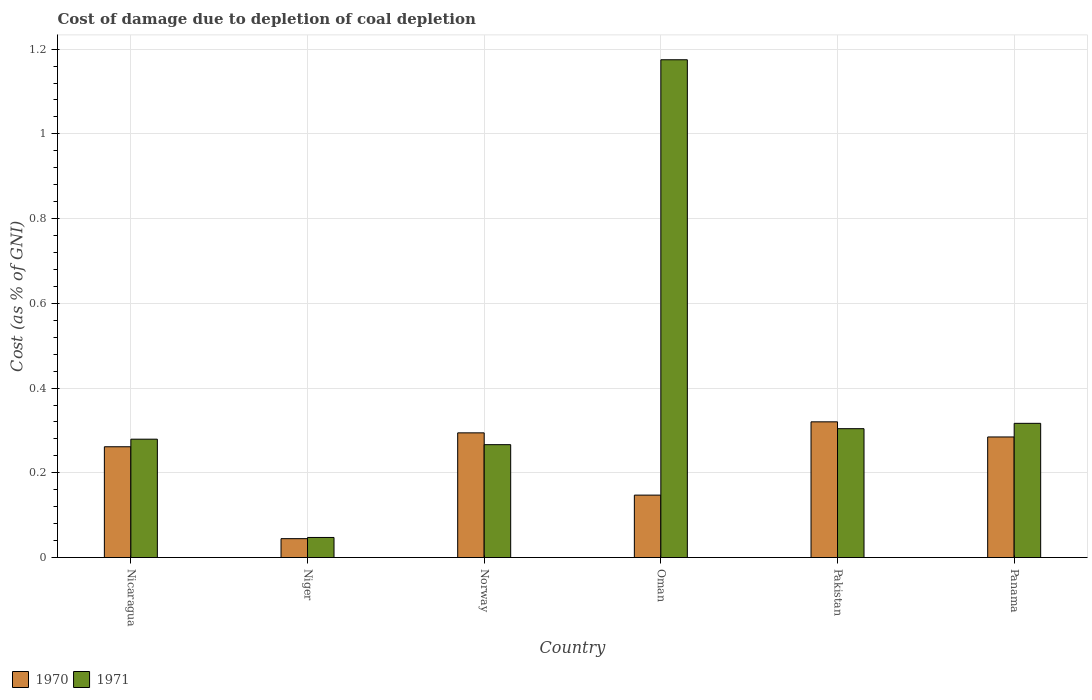How many different coloured bars are there?
Ensure brevity in your answer.  2. Are the number of bars per tick equal to the number of legend labels?
Make the answer very short. Yes. What is the label of the 1st group of bars from the left?
Offer a terse response. Nicaragua. In how many cases, is the number of bars for a given country not equal to the number of legend labels?
Offer a very short reply. 0. What is the cost of damage caused due to coal depletion in 1970 in Panama?
Make the answer very short. 0.28. Across all countries, what is the maximum cost of damage caused due to coal depletion in 1970?
Provide a short and direct response. 0.32. Across all countries, what is the minimum cost of damage caused due to coal depletion in 1971?
Your answer should be very brief. 0.05. In which country was the cost of damage caused due to coal depletion in 1970 maximum?
Provide a succinct answer. Pakistan. In which country was the cost of damage caused due to coal depletion in 1971 minimum?
Your response must be concise. Niger. What is the total cost of damage caused due to coal depletion in 1970 in the graph?
Your answer should be very brief. 1.35. What is the difference between the cost of damage caused due to coal depletion in 1971 in Niger and that in Panama?
Provide a succinct answer. -0.27. What is the difference between the cost of damage caused due to coal depletion in 1971 in Niger and the cost of damage caused due to coal depletion in 1970 in Nicaragua?
Ensure brevity in your answer.  -0.21. What is the average cost of damage caused due to coal depletion in 1971 per country?
Offer a very short reply. 0.4. What is the difference between the cost of damage caused due to coal depletion of/in 1971 and cost of damage caused due to coal depletion of/in 1970 in Niger?
Your response must be concise. 0. In how many countries, is the cost of damage caused due to coal depletion in 1971 greater than 0.08 %?
Your response must be concise. 5. What is the ratio of the cost of damage caused due to coal depletion in 1970 in Niger to that in Panama?
Your answer should be very brief. 0.16. Is the cost of damage caused due to coal depletion in 1971 in Norway less than that in Panama?
Keep it short and to the point. Yes. Is the difference between the cost of damage caused due to coal depletion in 1971 in Oman and Panama greater than the difference between the cost of damage caused due to coal depletion in 1970 in Oman and Panama?
Your answer should be very brief. Yes. What is the difference between the highest and the second highest cost of damage caused due to coal depletion in 1971?
Ensure brevity in your answer.  -0.86. What is the difference between the highest and the lowest cost of damage caused due to coal depletion in 1971?
Your answer should be compact. 1.13. In how many countries, is the cost of damage caused due to coal depletion in 1971 greater than the average cost of damage caused due to coal depletion in 1971 taken over all countries?
Offer a terse response. 1. Is the sum of the cost of damage caused due to coal depletion in 1970 in Pakistan and Panama greater than the maximum cost of damage caused due to coal depletion in 1971 across all countries?
Offer a very short reply. No. What does the 1st bar from the left in Oman represents?
Offer a terse response. 1970. How many bars are there?
Give a very brief answer. 12. Are all the bars in the graph horizontal?
Provide a succinct answer. No. What is the difference between two consecutive major ticks on the Y-axis?
Make the answer very short. 0.2. Where does the legend appear in the graph?
Provide a short and direct response. Bottom left. How many legend labels are there?
Offer a terse response. 2. How are the legend labels stacked?
Offer a terse response. Horizontal. What is the title of the graph?
Provide a succinct answer. Cost of damage due to depletion of coal depletion. What is the label or title of the Y-axis?
Give a very brief answer. Cost (as % of GNI). What is the Cost (as % of GNI) of 1970 in Nicaragua?
Provide a succinct answer. 0.26. What is the Cost (as % of GNI) in 1971 in Nicaragua?
Make the answer very short. 0.28. What is the Cost (as % of GNI) in 1970 in Niger?
Your answer should be compact. 0.04. What is the Cost (as % of GNI) in 1971 in Niger?
Provide a succinct answer. 0.05. What is the Cost (as % of GNI) in 1970 in Norway?
Provide a succinct answer. 0.29. What is the Cost (as % of GNI) of 1971 in Norway?
Keep it short and to the point. 0.27. What is the Cost (as % of GNI) of 1970 in Oman?
Provide a short and direct response. 0.15. What is the Cost (as % of GNI) in 1971 in Oman?
Provide a succinct answer. 1.17. What is the Cost (as % of GNI) in 1970 in Pakistan?
Keep it short and to the point. 0.32. What is the Cost (as % of GNI) of 1971 in Pakistan?
Give a very brief answer. 0.3. What is the Cost (as % of GNI) of 1970 in Panama?
Ensure brevity in your answer.  0.28. What is the Cost (as % of GNI) of 1971 in Panama?
Give a very brief answer. 0.32. Across all countries, what is the maximum Cost (as % of GNI) of 1970?
Your response must be concise. 0.32. Across all countries, what is the maximum Cost (as % of GNI) in 1971?
Your answer should be very brief. 1.17. Across all countries, what is the minimum Cost (as % of GNI) of 1970?
Offer a terse response. 0.04. Across all countries, what is the minimum Cost (as % of GNI) of 1971?
Ensure brevity in your answer.  0.05. What is the total Cost (as % of GNI) in 1970 in the graph?
Keep it short and to the point. 1.35. What is the total Cost (as % of GNI) of 1971 in the graph?
Your answer should be very brief. 2.39. What is the difference between the Cost (as % of GNI) of 1970 in Nicaragua and that in Niger?
Offer a very short reply. 0.22. What is the difference between the Cost (as % of GNI) of 1971 in Nicaragua and that in Niger?
Give a very brief answer. 0.23. What is the difference between the Cost (as % of GNI) in 1970 in Nicaragua and that in Norway?
Give a very brief answer. -0.03. What is the difference between the Cost (as % of GNI) in 1971 in Nicaragua and that in Norway?
Your answer should be very brief. 0.01. What is the difference between the Cost (as % of GNI) of 1970 in Nicaragua and that in Oman?
Your response must be concise. 0.11. What is the difference between the Cost (as % of GNI) in 1971 in Nicaragua and that in Oman?
Your answer should be very brief. -0.9. What is the difference between the Cost (as % of GNI) in 1970 in Nicaragua and that in Pakistan?
Provide a succinct answer. -0.06. What is the difference between the Cost (as % of GNI) of 1971 in Nicaragua and that in Pakistan?
Provide a succinct answer. -0.02. What is the difference between the Cost (as % of GNI) of 1970 in Nicaragua and that in Panama?
Your answer should be compact. -0.02. What is the difference between the Cost (as % of GNI) of 1971 in Nicaragua and that in Panama?
Your answer should be very brief. -0.04. What is the difference between the Cost (as % of GNI) in 1970 in Niger and that in Norway?
Keep it short and to the point. -0.25. What is the difference between the Cost (as % of GNI) in 1971 in Niger and that in Norway?
Give a very brief answer. -0.22. What is the difference between the Cost (as % of GNI) in 1970 in Niger and that in Oman?
Ensure brevity in your answer.  -0.1. What is the difference between the Cost (as % of GNI) in 1971 in Niger and that in Oman?
Your answer should be compact. -1.13. What is the difference between the Cost (as % of GNI) of 1970 in Niger and that in Pakistan?
Your answer should be very brief. -0.28. What is the difference between the Cost (as % of GNI) in 1971 in Niger and that in Pakistan?
Provide a succinct answer. -0.26. What is the difference between the Cost (as % of GNI) in 1970 in Niger and that in Panama?
Make the answer very short. -0.24. What is the difference between the Cost (as % of GNI) of 1971 in Niger and that in Panama?
Your answer should be compact. -0.27. What is the difference between the Cost (as % of GNI) in 1970 in Norway and that in Oman?
Offer a very short reply. 0.15. What is the difference between the Cost (as % of GNI) in 1971 in Norway and that in Oman?
Your answer should be very brief. -0.91. What is the difference between the Cost (as % of GNI) of 1970 in Norway and that in Pakistan?
Keep it short and to the point. -0.03. What is the difference between the Cost (as % of GNI) of 1971 in Norway and that in Pakistan?
Offer a terse response. -0.04. What is the difference between the Cost (as % of GNI) of 1970 in Norway and that in Panama?
Offer a terse response. 0.01. What is the difference between the Cost (as % of GNI) in 1971 in Norway and that in Panama?
Provide a short and direct response. -0.05. What is the difference between the Cost (as % of GNI) in 1970 in Oman and that in Pakistan?
Your response must be concise. -0.17. What is the difference between the Cost (as % of GNI) in 1971 in Oman and that in Pakistan?
Ensure brevity in your answer.  0.87. What is the difference between the Cost (as % of GNI) in 1970 in Oman and that in Panama?
Provide a short and direct response. -0.14. What is the difference between the Cost (as % of GNI) in 1971 in Oman and that in Panama?
Your answer should be very brief. 0.86. What is the difference between the Cost (as % of GNI) in 1970 in Pakistan and that in Panama?
Ensure brevity in your answer.  0.04. What is the difference between the Cost (as % of GNI) in 1971 in Pakistan and that in Panama?
Offer a terse response. -0.01. What is the difference between the Cost (as % of GNI) in 1970 in Nicaragua and the Cost (as % of GNI) in 1971 in Niger?
Provide a succinct answer. 0.21. What is the difference between the Cost (as % of GNI) in 1970 in Nicaragua and the Cost (as % of GNI) in 1971 in Norway?
Your answer should be very brief. -0. What is the difference between the Cost (as % of GNI) in 1970 in Nicaragua and the Cost (as % of GNI) in 1971 in Oman?
Offer a very short reply. -0.91. What is the difference between the Cost (as % of GNI) of 1970 in Nicaragua and the Cost (as % of GNI) of 1971 in Pakistan?
Offer a very short reply. -0.04. What is the difference between the Cost (as % of GNI) in 1970 in Nicaragua and the Cost (as % of GNI) in 1971 in Panama?
Provide a succinct answer. -0.06. What is the difference between the Cost (as % of GNI) of 1970 in Niger and the Cost (as % of GNI) of 1971 in Norway?
Offer a terse response. -0.22. What is the difference between the Cost (as % of GNI) of 1970 in Niger and the Cost (as % of GNI) of 1971 in Oman?
Offer a terse response. -1.13. What is the difference between the Cost (as % of GNI) of 1970 in Niger and the Cost (as % of GNI) of 1971 in Pakistan?
Your answer should be very brief. -0.26. What is the difference between the Cost (as % of GNI) of 1970 in Niger and the Cost (as % of GNI) of 1971 in Panama?
Offer a terse response. -0.27. What is the difference between the Cost (as % of GNI) in 1970 in Norway and the Cost (as % of GNI) in 1971 in Oman?
Offer a terse response. -0.88. What is the difference between the Cost (as % of GNI) in 1970 in Norway and the Cost (as % of GNI) in 1971 in Pakistan?
Ensure brevity in your answer.  -0.01. What is the difference between the Cost (as % of GNI) in 1970 in Norway and the Cost (as % of GNI) in 1971 in Panama?
Keep it short and to the point. -0.02. What is the difference between the Cost (as % of GNI) of 1970 in Oman and the Cost (as % of GNI) of 1971 in Pakistan?
Offer a terse response. -0.16. What is the difference between the Cost (as % of GNI) of 1970 in Oman and the Cost (as % of GNI) of 1971 in Panama?
Your answer should be very brief. -0.17. What is the difference between the Cost (as % of GNI) in 1970 in Pakistan and the Cost (as % of GNI) in 1971 in Panama?
Your answer should be very brief. 0. What is the average Cost (as % of GNI) in 1970 per country?
Your answer should be very brief. 0.23. What is the average Cost (as % of GNI) in 1971 per country?
Your answer should be compact. 0.4. What is the difference between the Cost (as % of GNI) in 1970 and Cost (as % of GNI) in 1971 in Nicaragua?
Provide a short and direct response. -0.02. What is the difference between the Cost (as % of GNI) of 1970 and Cost (as % of GNI) of 1971 in Niger?
Your answer should be compact. -0. What is the difference between the Cost (as % of GNI) of 1970 and Cost (as % of GNI) of 1971 in Norway?
Offer a very short reply. 0.03. What is the difference between the Cost (as % of GNI) in 1970 and Cost (as % of GNI) in 1971 in Oman?
Give a very brief answer. -1.03. What is the difference between the Cost (as % of GNI) of 1970 and Cost (as % of GNI) of 1971 in Pakistan?
Provide a short and direct response. 0.02. What is the difference between the Cost (as % of GNI) in 1970 and Cost (as % of GNI) in 1971 in Panama?
Your answer should be compact. -0.03. What is the ratio of the Cost (as % of GNI) of 1970 in Nicaragua to that in Niger?
Give a very brief answer. 5.87. What is the ratio of the Cost (as % of GNI) in 1971 in Nicaragua to that in Niger?
Your answer should be very brief. 5.9. What is the ratio of the Cost (as % of GNI) in 1970 in Nicaragua to that in Norway?
Your answer should be very brief. 0.89. What is the ratio of the Cost (as % of GNI) of 1971 in Nicaragua to that in Norway?
Your response must be concise. 1.05. What is the ratio of the Cost (as % of GNI) in 1970 in Nicaragua to that in Oman?
Provide a succinct answer. 1.77. What is the ratio of the Cost (as % of GNI) in 1971 in Nicaragua to that in Oman?
Your answer should be very brief. 0.24. What is the ratio of the Cost (as % of GNI) in 1970 in Nicaragua to that in Pakistan?
Offer a terse response. 0.82. What is the ratio of the Cost (as % of GNI) of 1971 in Nicaragua to that in Pakistan?
Offer a terse response. 0.92. What is the ratio of the Cost (as % of GNI) of 1970 in Nicaragua to that in Panama?
Make the answer very short. 0.92. What is the ratio of the Cost (as % of GNI) in 1971 in Nicaragua to that in Panama?
Offer a very short reply. 0.88. What is the ratio of the Cost (as % of GNI) of 1970 in Niger to that in Norway?
Provide a short and direct response. 0.15. What is the ratio of the Cost (as % of GNI) in 1971 in Niger to that in Norway?
Offer a very short reply. 0.18. What is the ratio of the Cost (as % of GNI) of 1970 in Niger to that in Oman?
Give a very brief answer. 0.3. What is the ratio of the Cost (as % of GNI) of 1971 in Niger to that in Oman?
Provide a succinct answer. 0.04. What is the ratio of the Cost (as % of GNI) of 1970 in Niger to that in Pakistan?
Make the answer very short. 0.14. What is the ratio of the Cost (as % of GNI) of 1971 in Niger to that in Pakistan?
Offer a terse response. 0.16. What is the ratio of the Cost (as % of GNI) in 1970 in Niger to that in Panama?
Your response must be concise. 0.16. What is the ratio of the Cost (as % of GNI) in 1971 in Niger to that in Panama?
Your response must be concise. 0.15. What is the ratio of the Cost (as % of GNI) of 1970 in Norway to that in Oman?
Provide a succinct answer. 2. What is the ratio of the Cost (as % of GNI) of 1971 in Norway to that in Oman?
Give a very brief answer. 0.23. What is the ratio of the Cost (as % of GNI) of 1970 in Norway to that in Pakistan?
Provide a short and direct response. 0.92. What is the ratio of the Cost (as % of GNI) in 1971 in Norway to that in Pakistan?
Your answer should be very brief. 0.88. What is the ratio of the Cost (as % of GNI) in 1970 in Norway to that in Panama?
Give a very brief answer. 1.03. What is the ratio of the Cost (as % of GNI) of 1971 in Norway to that in Panama?
Keep it short and to the point. 0.84. What is the ratio of the Cost (as % of GNI) of 1970 in Oman to that in Pakistan?
Ensure brevity in your answer.  0.46. What is the ratio of the Cost (as % of GNI) of 1971 in Oman to that in Pakistan?
Ensure brevity in your answer.  3.86. What is the ratio of the Cost (as % of GNI) in 1970 in Oman to that in Panama?
Your answer should be very brief. 0.52. What is the ratio of the Cost (as % of GNI) in 1971 in Oman to that in Panama?
Offer a very short reply. 3.71. What is the ratio of the Cost (as % of GNI) of 1970 in Pakistan to that in Panama?
Your response must be concise. 1.13. What is the ratio of the Cost (as % of GNI) in 1971 in Pakistan to that in Panama?
Keep it short and to the point. 0.96. What is the difference between the highest and the second highest Cost (as % of GNI) in 1970?
Ensure brevity in your answer.  0.03. What is the difference between the highest and the second highest Cost (as % of GNI) in 1971?
Your answer should be very brief. 0.86. What is the difference between the highest and the lowest Cost (as % of GNI) in 1970?
Keep it short and to the point. 0.28. What is the difference between the highest and the lowest Cost (as % of GNI) of 1971?
Offer a very short reply. 1.13. 